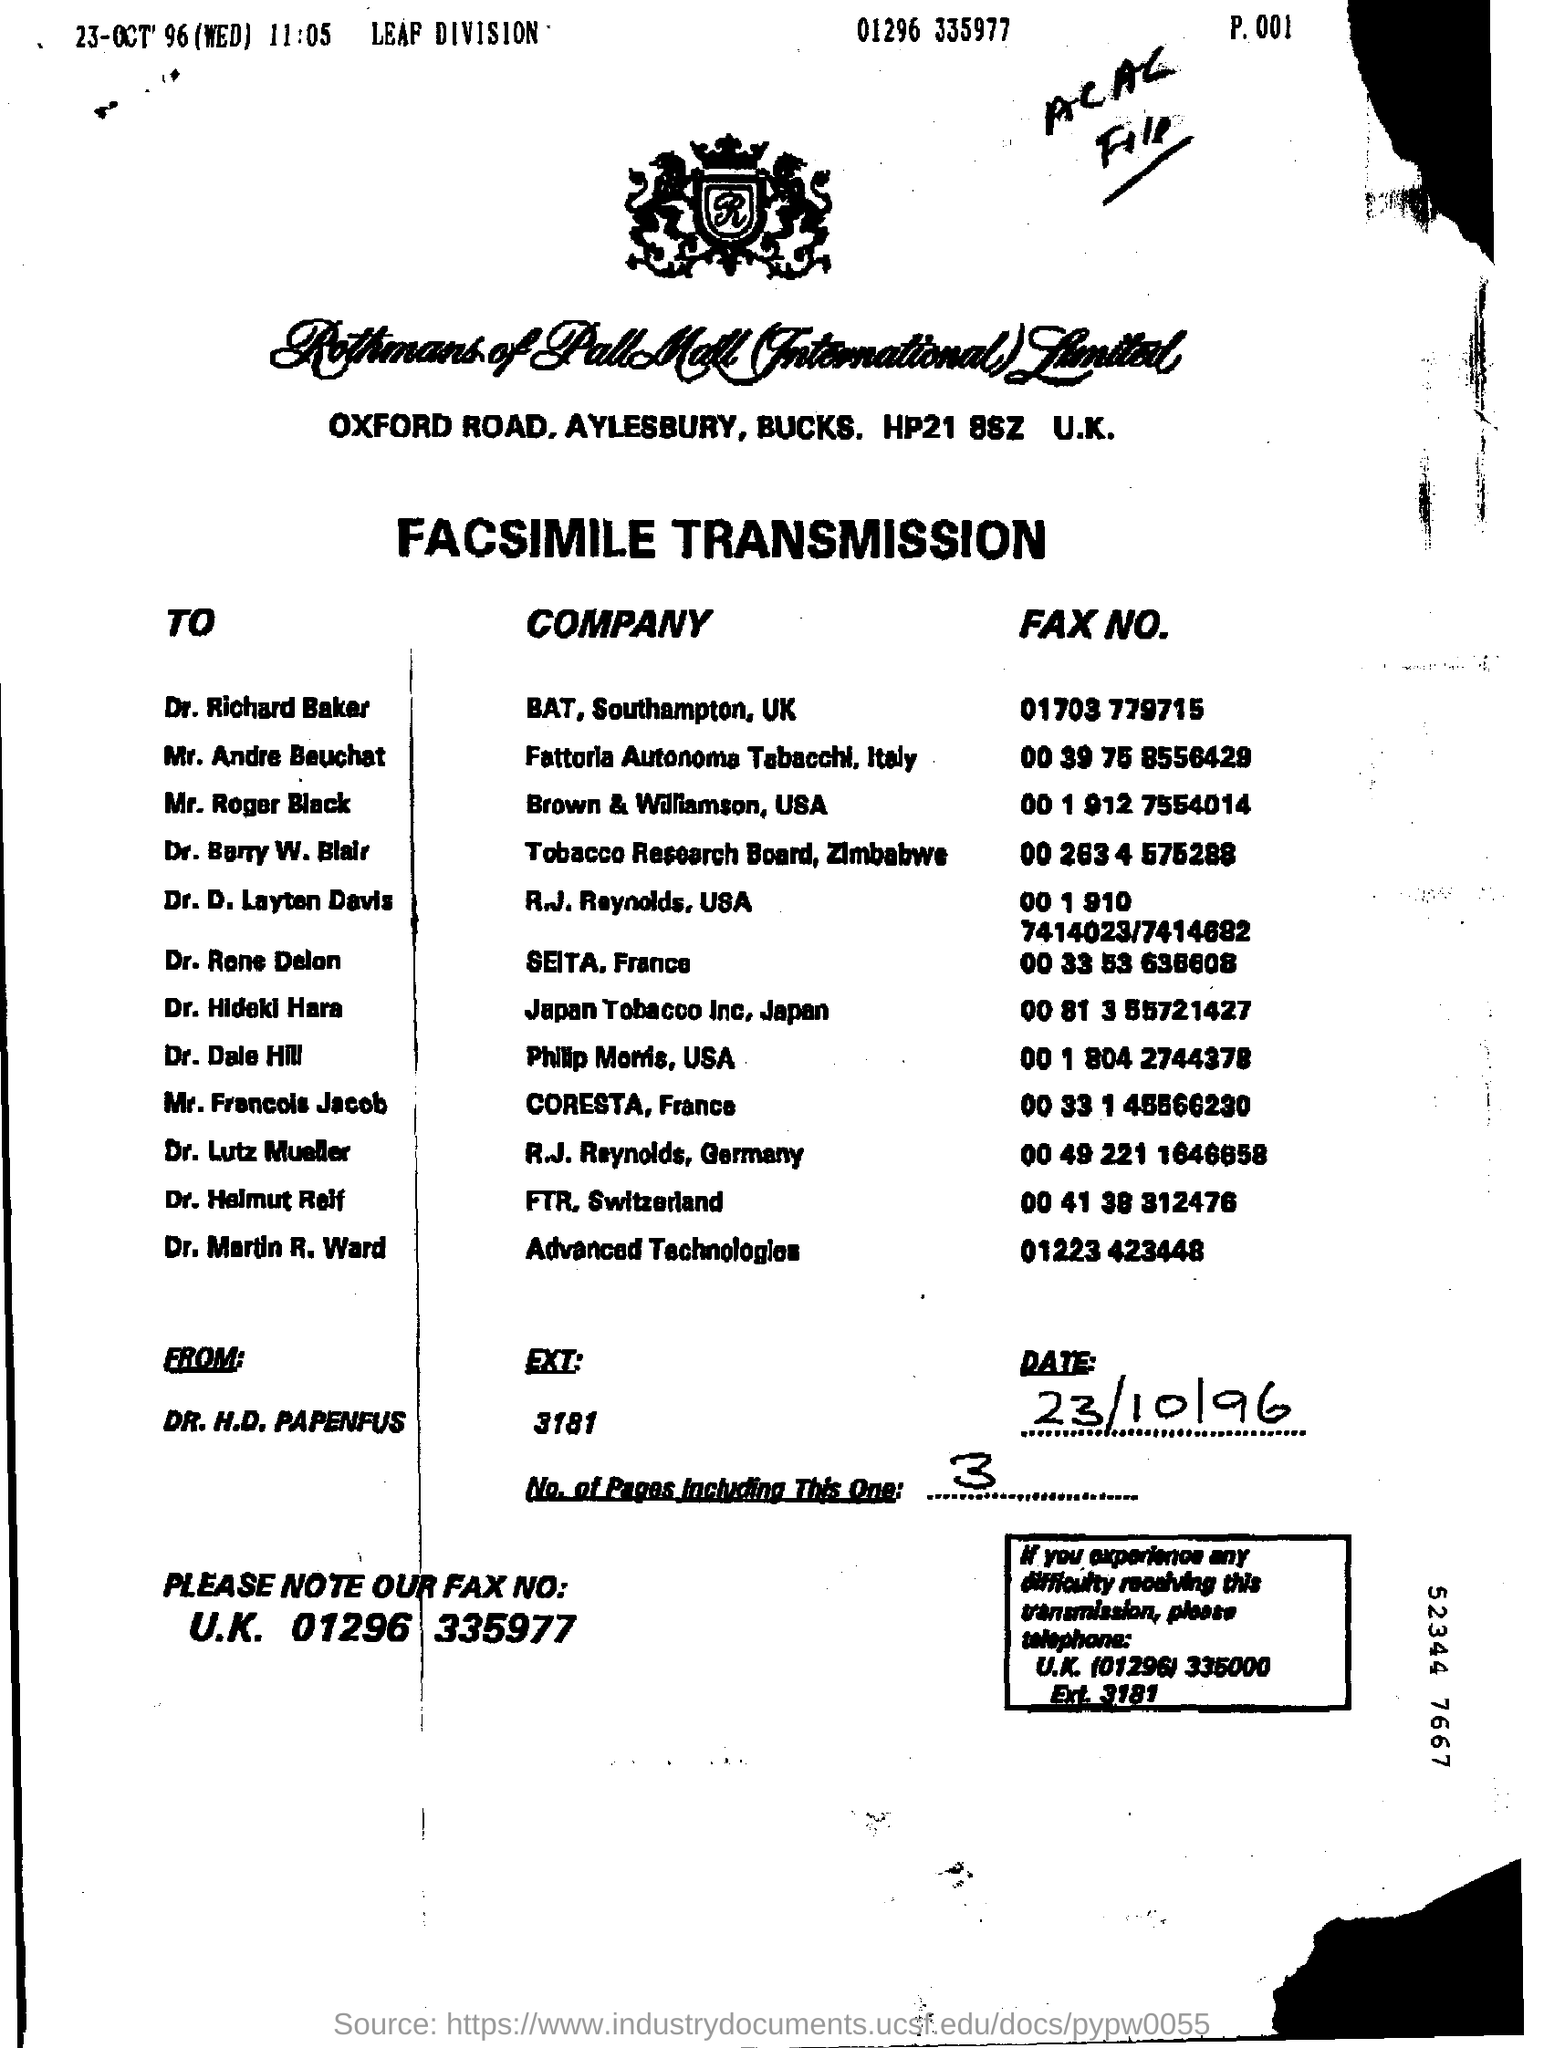Mention a couple of crucial points in this snapshot. There are a total of 3 pages, including this one. I would like to inquire about the fax number for Dr. Martin R. Ward, which is 01223 423448.. The extension for Dr. H. D. Papenfus is 3181. The Tobacco Research Board, Zimbabwe is the company for Dr. Barry W. Blair. The date is October 23, 1996. 